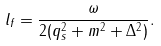<formula> <loc_0><loc_0><loc_500><loc_500>l _ { f } = \frac { \omega } { 2 ( q _ { s } ^ { 2 } + m ^ { 2 } + \Delta ^ { 2 } ) } .</formula> 